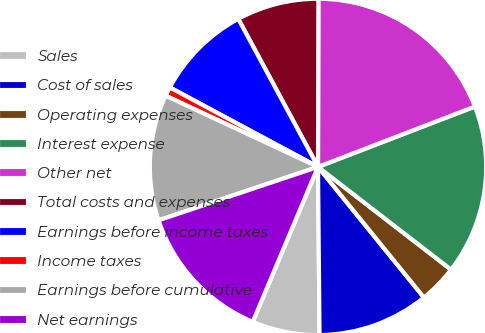<chart> <loc_0><loc_0><loc_500><loc_500><pie_chart><fcel>Sales<fcel>Cost of sales<fcel>Operating expenses<fcel>Interest expense<fcel>Other net<fcel>Total costs and expenses<fcel>Earnings before income taxes<fcel>Income taxes<fcel>Earnings before cumulative<fcel>Net earnings<nl><fcel>6.49%<fcel>10.7%<fcel>3.69%<fcel>16.31%<fcel>19.12%<fcel>7.9%<fcel>9.3%<fcel>0.88%<fcel>12.1%<fcel>13.51%<nl></chart> 